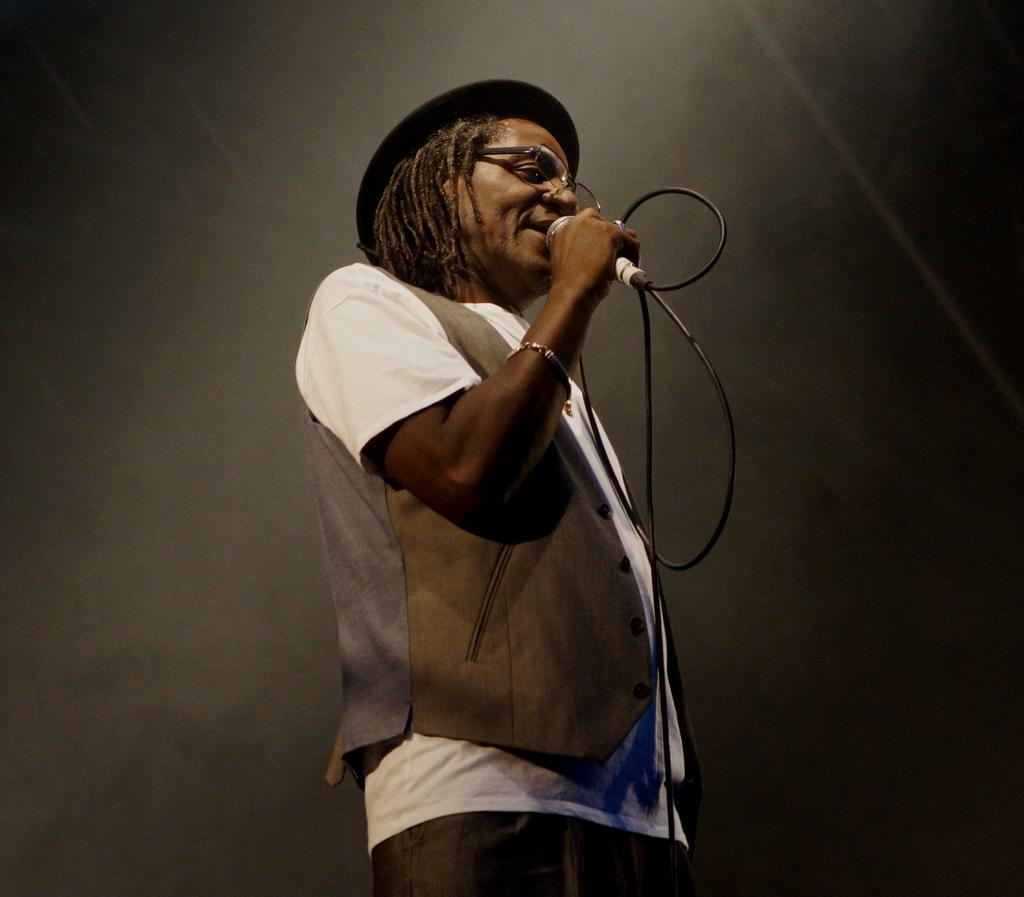Who is the main subject in the image? There is a man in the middle of the image. What is the man holding in the image? The man is holding a microphone. What can be observed about the background of the image? The background of the image is dark. What type of jeans is the man wearing in the image? There is no information about the man's jeans in the image, so we cannot determine the type of jeans he is wearing. 